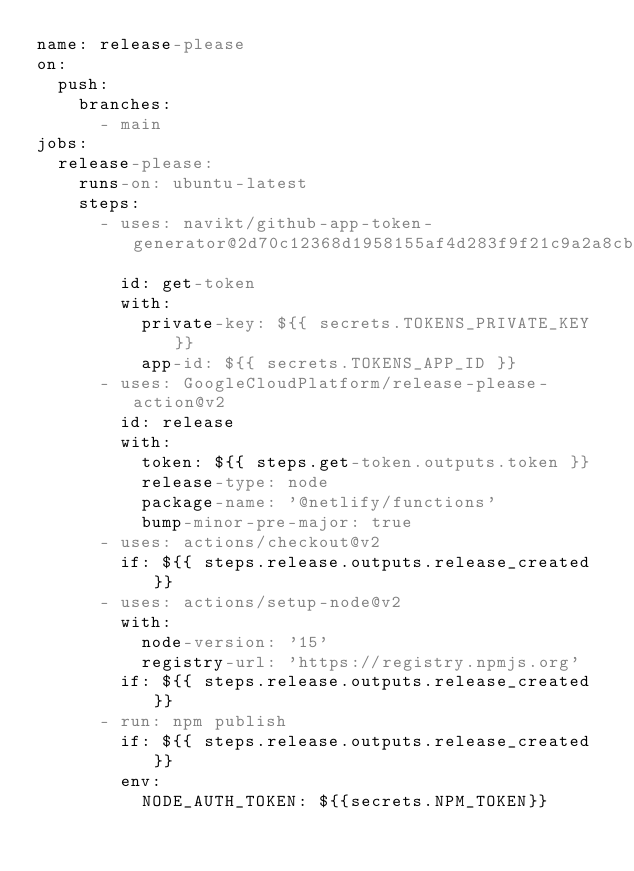Convert code to text. <code><loc_0><loc_0><loc_500><loc_500><_YAML_>name: release-please
on:
  push:
    branches:
      - main
jobs:
  release-please:
    runs-on: ubuntu-latest
    steps:
      - uses: navikt/github-app-token-generator@2d70c12368d1958155af4d283f9f21c9a2a8cb98
        id: get-token
        with:
          private-key: ${{ secrets.TOKENS_PRIVATE_KEY }}
          app-id: ${{ secrets.TOKENS_APP_ID }}
      - uses: GoogleCloudPlatform/release-please-action@v2
        id: release
        with:
          token: ${{ steps.get-token.outputs.token }}
          release-type: node
          package-name: '@netlify/functions'
          bump-minor-pre-major: true
      - uses: actions/checkout@v2
        if: ${{ steps.release.outputs.release_created }}
      - uses: actions/setup-node@v2
        with:
          node-version: '15'
          registry-url: 'https://registry.npmjs.org'
        if: ${{ steps.release.outputs.release_created }}
      - run: npm publish
        if: ${{ steps.release.outputs.release_created }}
        env:
          NODE_AUTH_TOKEN: ${{secrets.NPM_TOKEN}}
</code> 